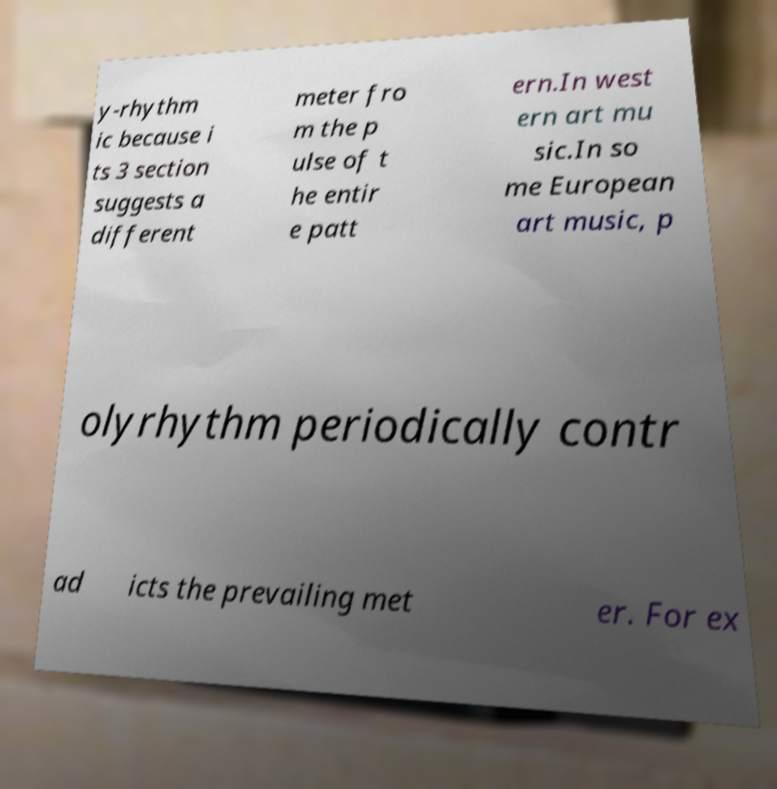I need the written content from this picture converted into text. Can you do that? y-rhythm ic because i ts 3 section suggests a different meter fro m the p ulse of t he entir e patt ern.In west ern art mu sic.In so me European art music, p olyrhythm periodically contr ad icts the prevailing met er. For ex 